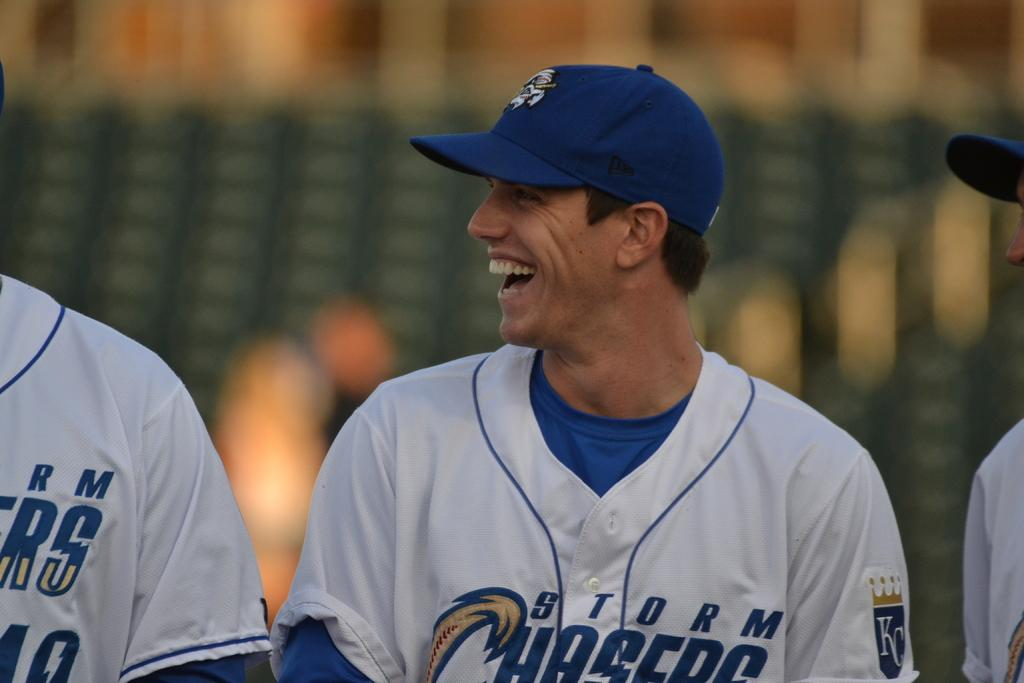<image>
Summarize the visual content of the image. The baseball team shown here is called the Storm Chasers 